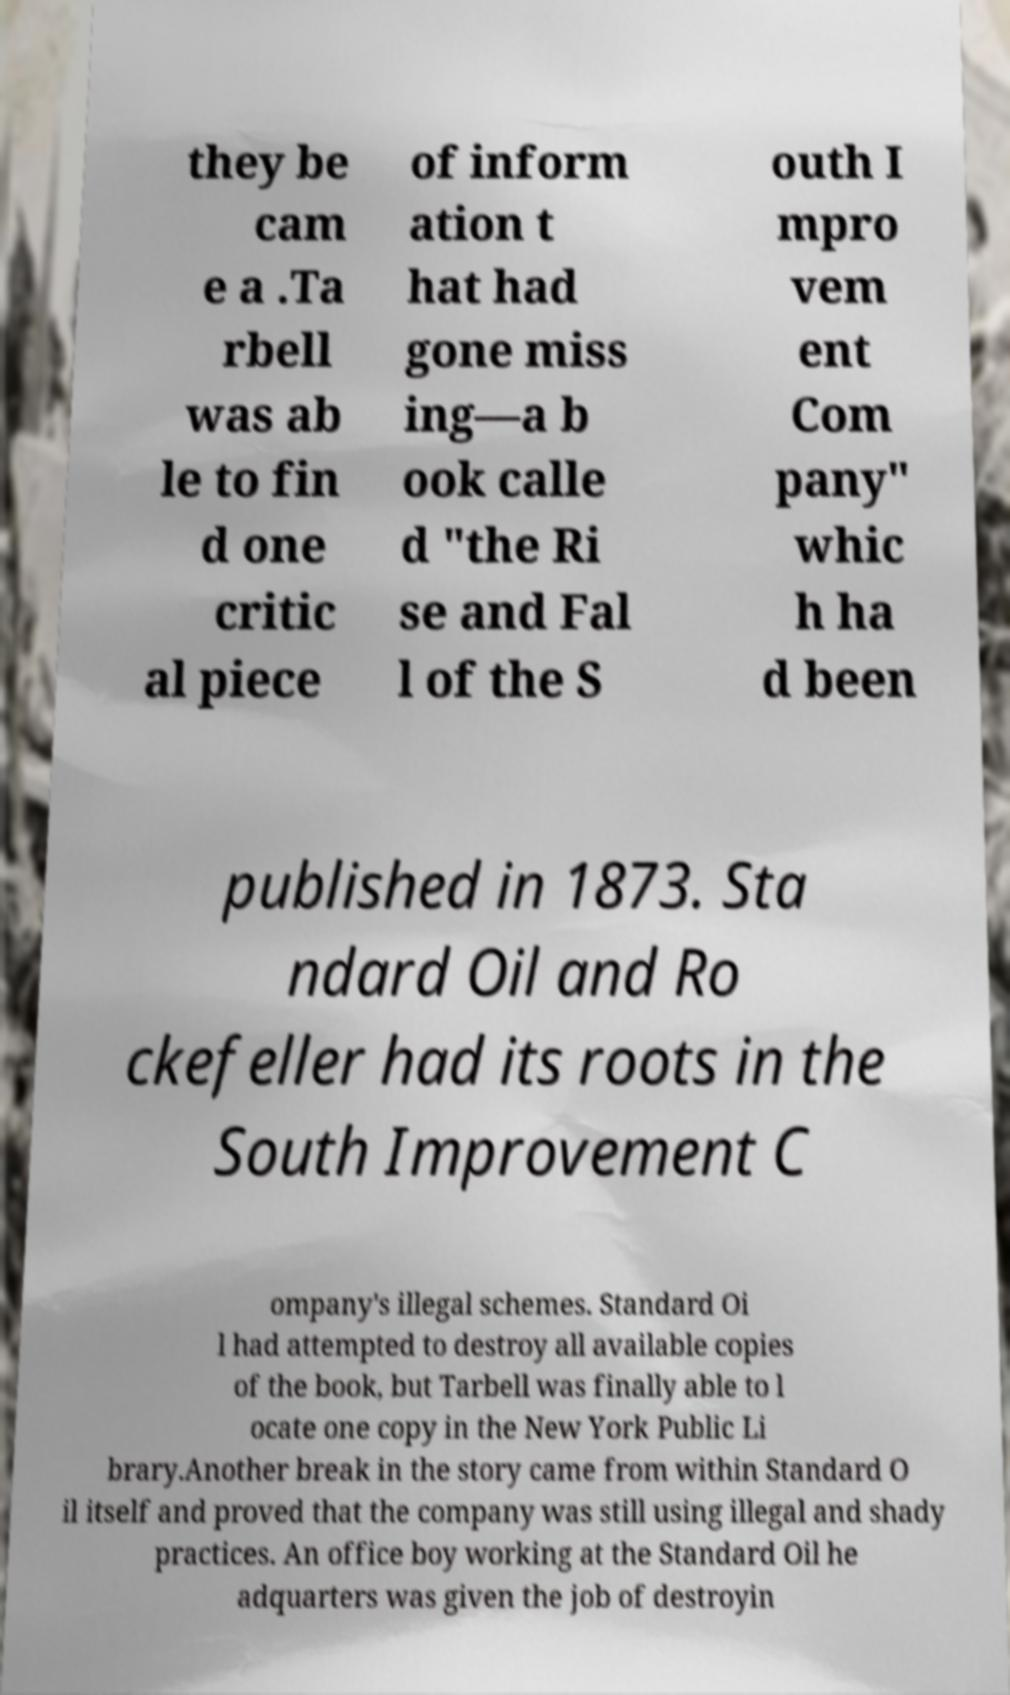Could you assist in decoding the text presented in this image and type it out clearly? they be cam e a .Ta rbell was ab le to fin d one critic al piece of inform ation t hat had gone miss ing—a b ook calle d "the Ri se and Fal l of the S outh I mpro vem ent Com pany" whic h ha d been published in 1873. Sta ndard Oil and Ro ckefeller had its roots in the South Improvement C ompany's illegal schemes. Standard Oi l had attempted to destroy all available copies of the book, but Tarbell was finally able to l ocate one copy in the New York Public Li brary.Another break in the story came from within Standard O il itself and proved that the company was still using illegal and shady practices. An office boy working at the Standard Oil he adquarters was given the job of destroyin 